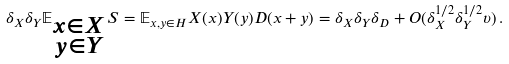<formula> <loc_0><loc_0><loc_500><loc_500>\delta _ { X } \delta _ { Y } \mathbb { E } _ { \substack { x \in X \\ y \in Y } } S & = \mathbb { E } _ { x , y \in H } X ( x ) Y ( y ) D ( x + y ) = \delta _ { X } \delta _ { Y } \delta _ { D } + O ( \delta _ { X } ^ { 1 / 2 } \delta _ { Y } ^ { 1 / 2 } \upsilon ) \, .</formula> 